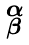Convert formula to latex. <formula><loc_0><loc_0><loc_500><loc_500>\begin{smallmatrix} \alpha \\ \beta \end{smallmatrix}</formula> 